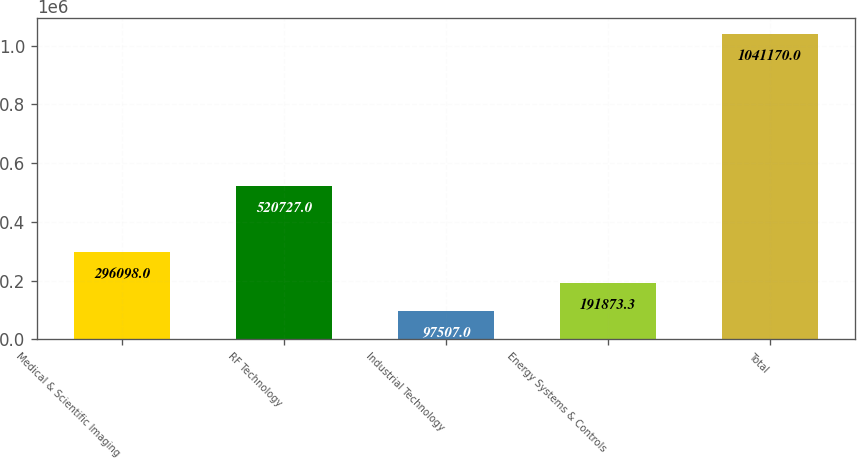<chart> <loc_0><loc_0><loc_500><loc_500><bar_chart><fcel>Medical & Scientific Imaging<fcel>RF Technology<fcel>Industrial Technology<fcel>Energy Systems & Controls<fcel>Total<nl><fcel>296098<fcel>520727<fcel>97507<fcel>191873<fcel>1.04117e+06<nl></chart> 